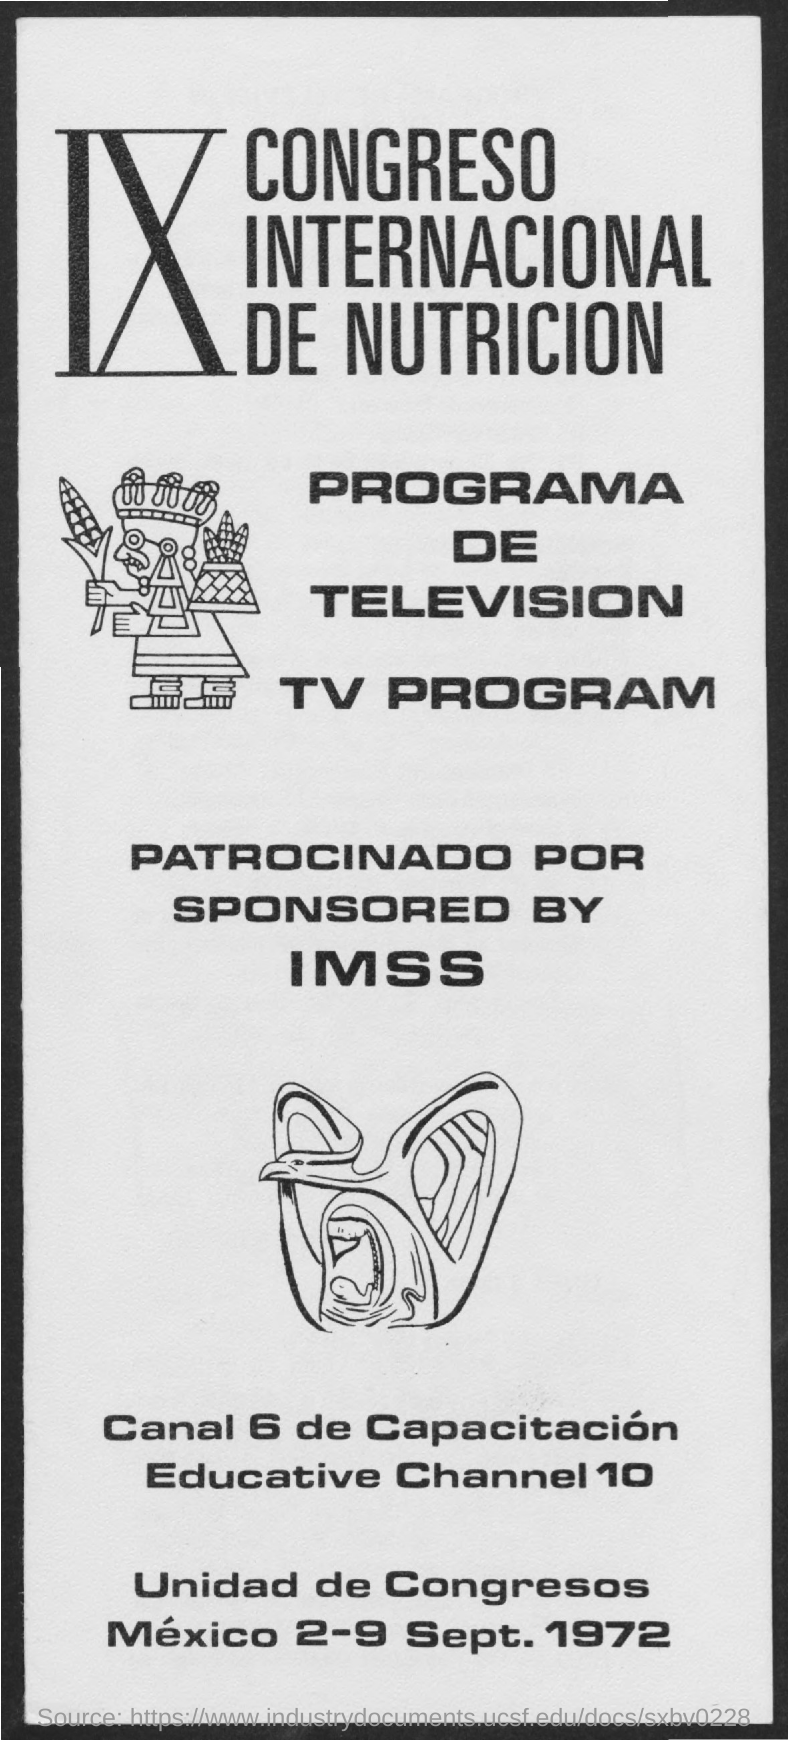Highlight a few significant elements in this photo. The dates at the bottom of the page are "2-9 Sept. 1972. 